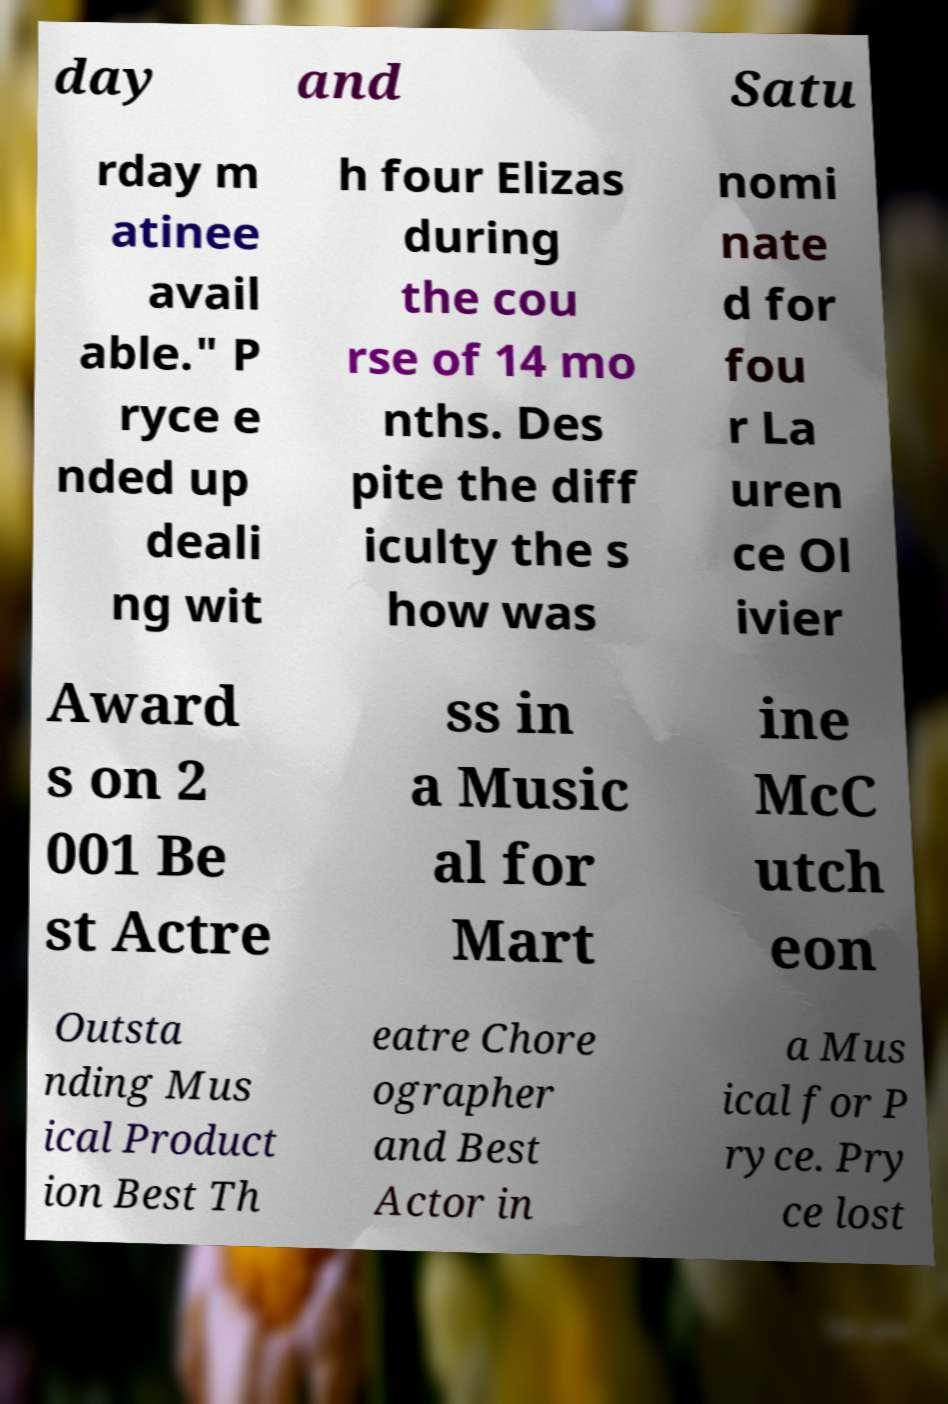What messages or text are displayed in this image? I need them in a readable, typed format. day and Satu rday m atinee avail able." P ryce e nded up deali ng wit h four Elizas during the cou rse of 14 mo nths. Des pite the diff iculty the s how was nomi nate d for fou r La uren ce Ol ivier Award s on 2 001 Be st Actre ss in a Music al for Mart ine McC utch eon Outsta nding Mus ical Product ion Best Th eatre Chore ographer and Best Actor in a Mus ical for P ryce. Pry ce lost 